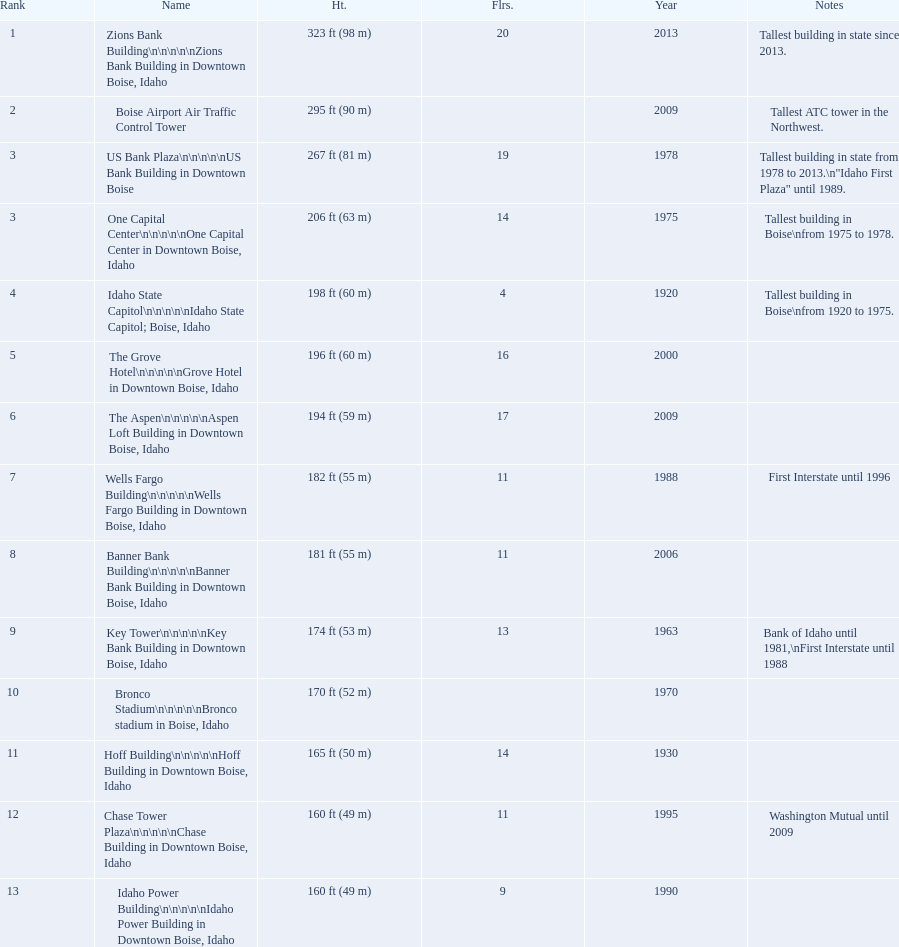How many buildings have at least ten floors? 10. 